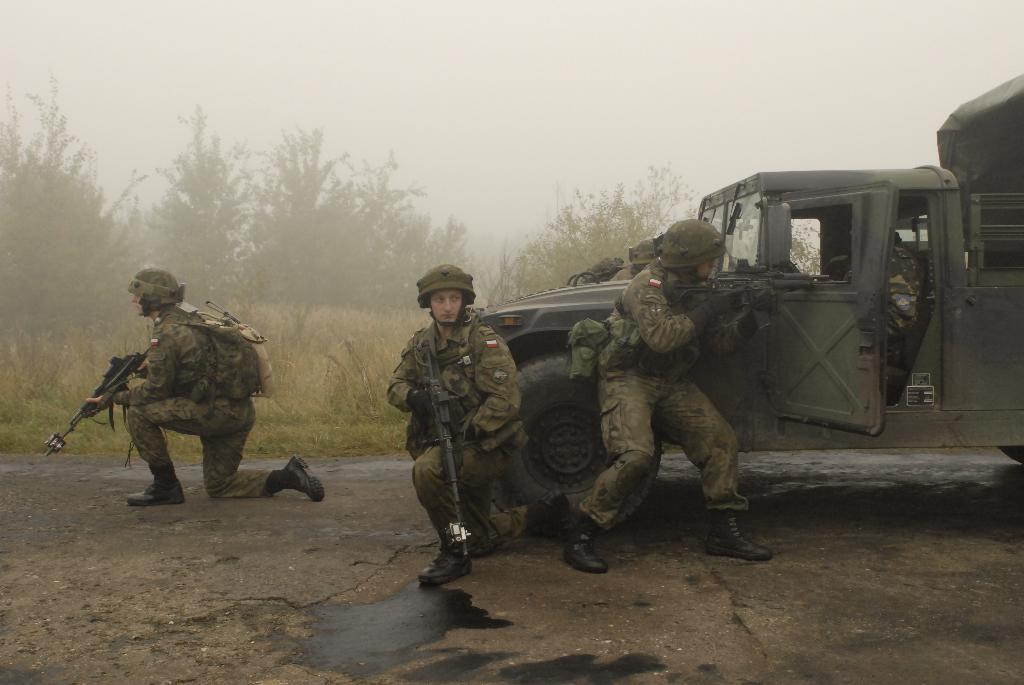What are the persons in the image holding? The persons in the image are holding guns. What is the person in the car doing? The person is sitting in a car on the road. What can be seen in the background of the image? There are plants, trees, and the sky visible in the background of the image. What type of produce is being harvested in the image? There is no produce being harvested in the image; it features persons holding guns and a person sitting in a car. What kind of breakfast is being prepared in the image? There is no breakfast being prepared in the image; it does not depict any food or cooking activities. 